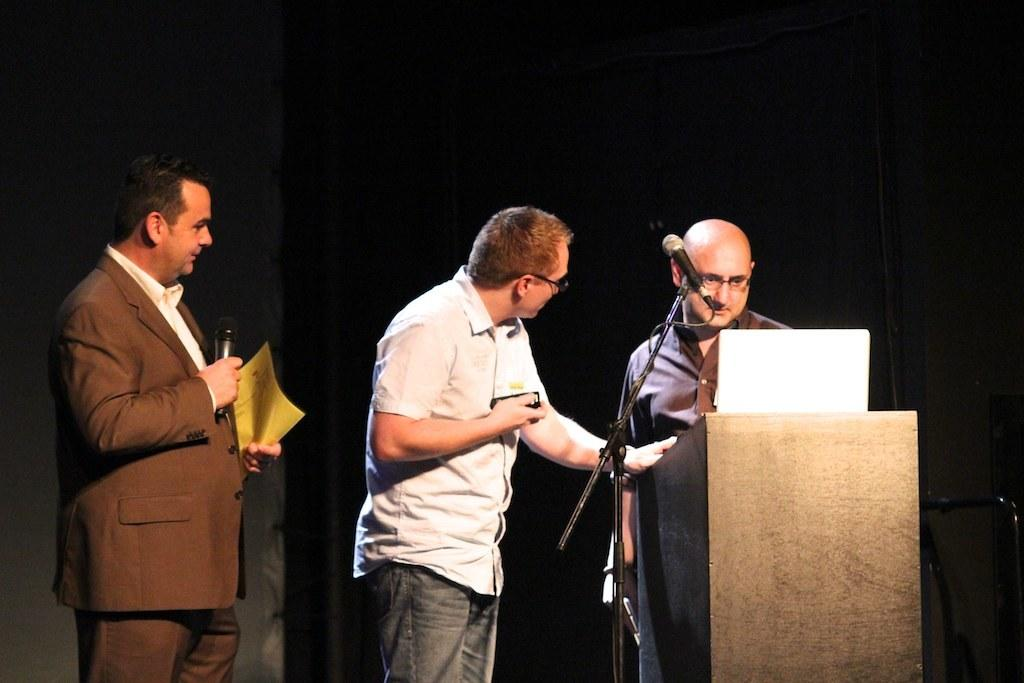How many people are in the image? There are three men in the image. Where are the men located in the image? The men are standing on a stage. What is the color of the background in the image? The background of the image is dark. What is the man in the brown suit holding? The man in the brown suit is holding a microphone. What type of lamp is hanging from the ceiling in the image? There is no lamp visible in the image; it only features three men standing on a stage. How many stockings are worn by the man in the brown suit? The man in the brown suit is not wearing any stockings, as he is wearing a suit and not hosiery. 